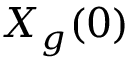Convert formula to latex. <formula><loc_0><loc_0><loc_500><loc_500>X _ { g } ( 0 )</formula> 